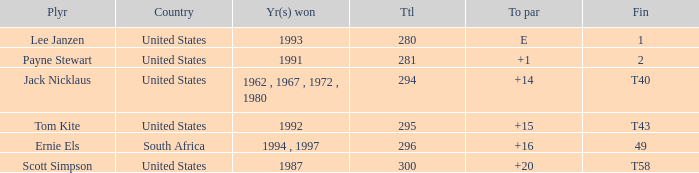What Country is Tom Kite from? United States. 